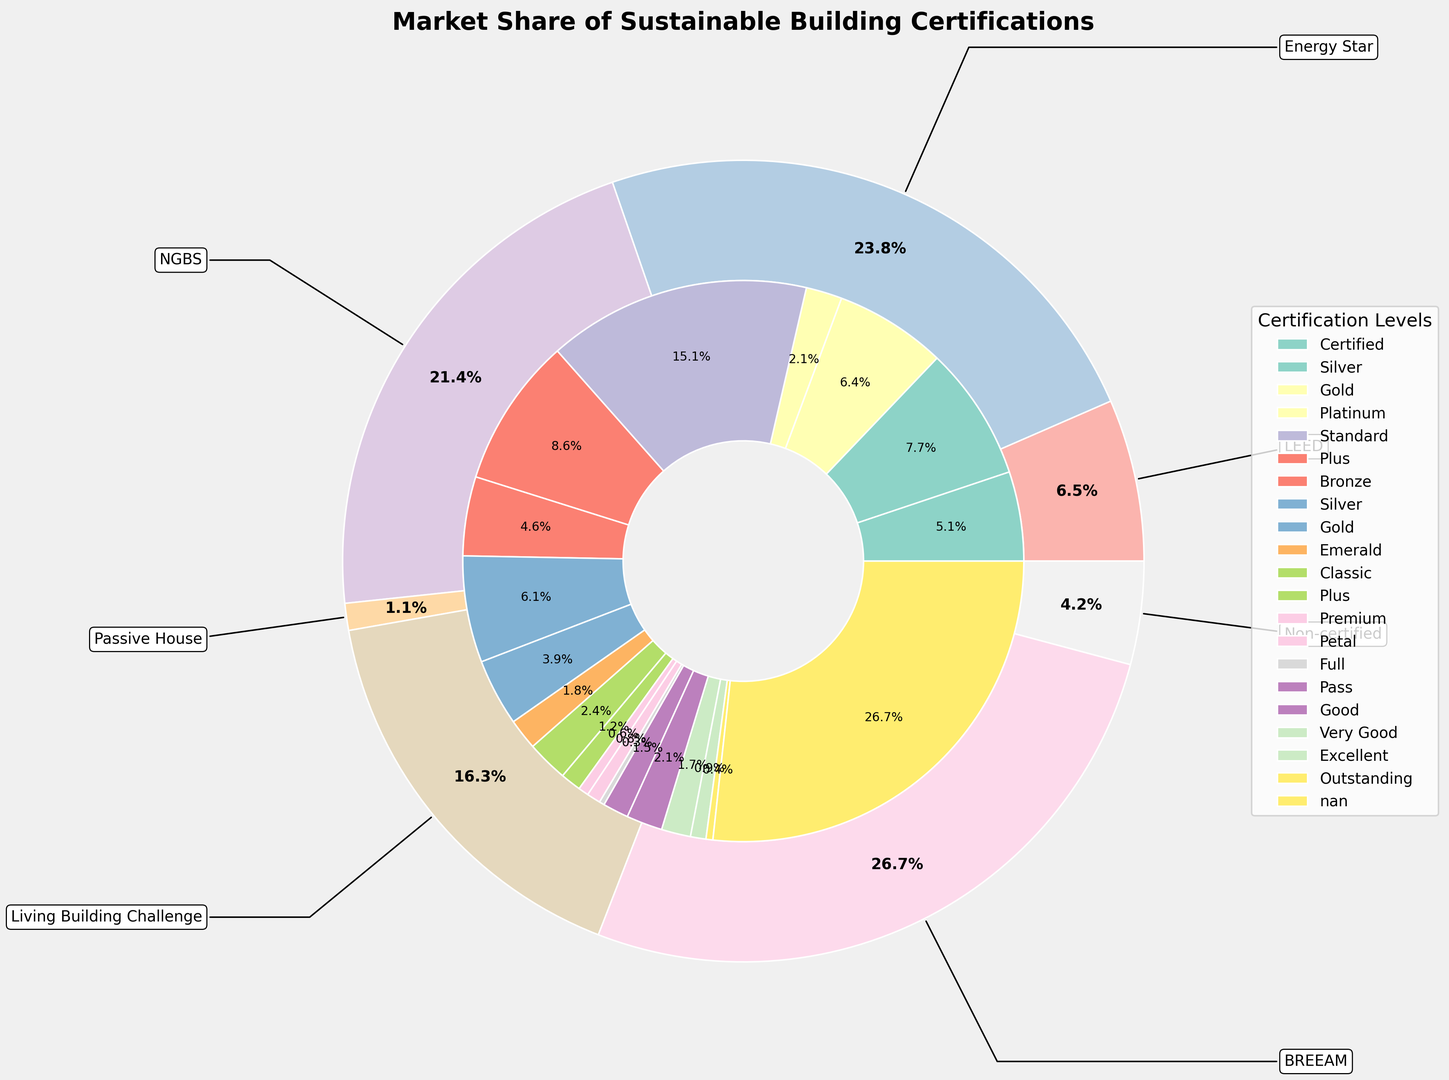What's the total market share of LEED Platinum and Energy Star Plus levels? First, find the market share for LEED Platinum (2.1%) and Energy Star Plus (8.7%). Then, sum these values: 2.1 + 8.7 = 10.8%.
Answer: 10.8% Which certification has the highest overall market share? Based on the outer pie chart, the largest segment corresponds to Energy Star with the market share being the highest.
Answer: Energy Star What's the difference in market share between NGBS Silver and Passive House Classic? Find the market share for NGBS Silver (6.2%) and Passive House Classic (2.4%), then calculate the difference: 6.2 - 2.4 = 3.8%.
Answer: 3.8% Which certification level within LEED has the highest market share? Look at the inner chart sections under LEED. The highest percentage is LEED Silver at 7.8%.
Answer: LEED Silver What is the market share for non-certified homes, and how does it compare to the total market share of all LEED-certified levels combined? Non-certified homes have a market share of 27.0%. Sum the market shares for all LEED levels (5.2 + 7.8 + 6.5 + 2.1 = 21.6%). Non-certified: 27.0%; LEED combined: 21.6%. Non-certified is greater.
Answer: Non-certified: 27.0%, LEED combined: 21.6% Between BREEAM Excellent and Living Building Challenge Full, which has the smaller market share? BREEAM Excellent has a market share of 0.9%, while Living Building Challenge Full has a market share of 0.3%. Therefore, Living Building Challenge Full has the smaller market share.
Answer: Living Building Challenge Full What is the total market share for all levels of Passive House certification? Add the market shares for Passive House Classic (2.4%), Passive House Plus (1.2%), and Passive House Premium (0.6%): 2.4 + 1.2 + 0.6 = 4.2%.
Answer: 4.2% How does the market share for the Bronze level within NGBS compare to the Premium level within Passive House? NGBS Bronze has a market share of 4.6%, and Passive House Premium has a market share of 0.6%. The market share for NGBS Bronze is greater.
Answer: NGBS Bronze is greater Which certification level is visually represented by the smallest segment in the inner pie chart? The smallest segment in the inner pie chart corresponds to Living Building Challenge Full with a market share of 0.3%.
Answer: Living Building Challenge Full What's the market share difference between BREEAM Good and BREEAM Very Good? Find the market share for BREEAM Good (2.1%) and BREEAM Very Good (1.7%). Then calculate the difference: 2.1 - 1.7 = 0.4%.
Answer: 0.4% 